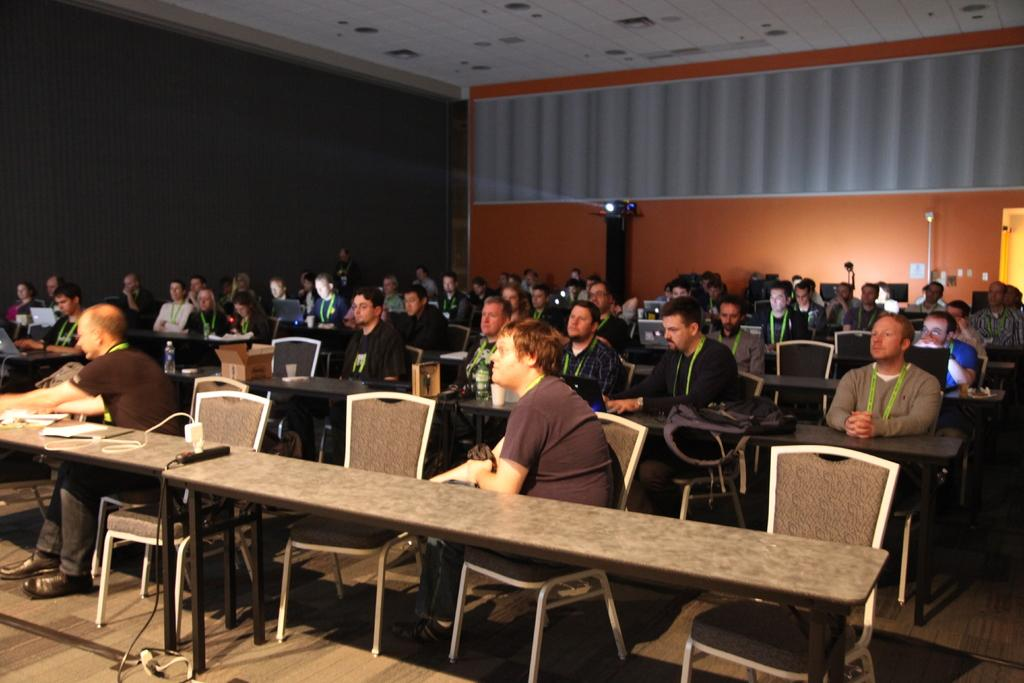What is happening in the image involving a group of people? There is a group of people in the image, and they are sitting on chairs. What are the people doing while sitting on the chairs? The people are working on laptops. Is there any equipment related to presentations or visual aids in the image? Yes, there is a projector in the image. Can you see a wren perched on the projector in the image? There is no wren present in the image; it features a group of people working on laptops and a projector. What type of notebook is being used by the people in the image? The image does not show any notebooks being used by the people; they are working on laptops. 